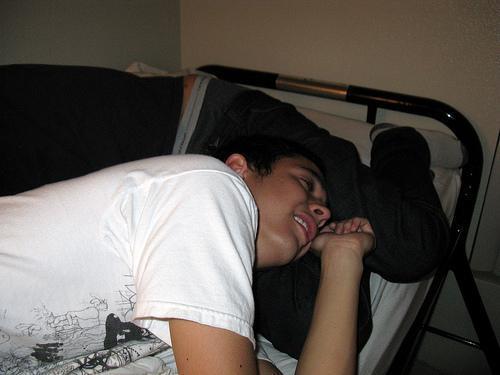How many white objects are on the bed?
Give a very brief answer. 2. 